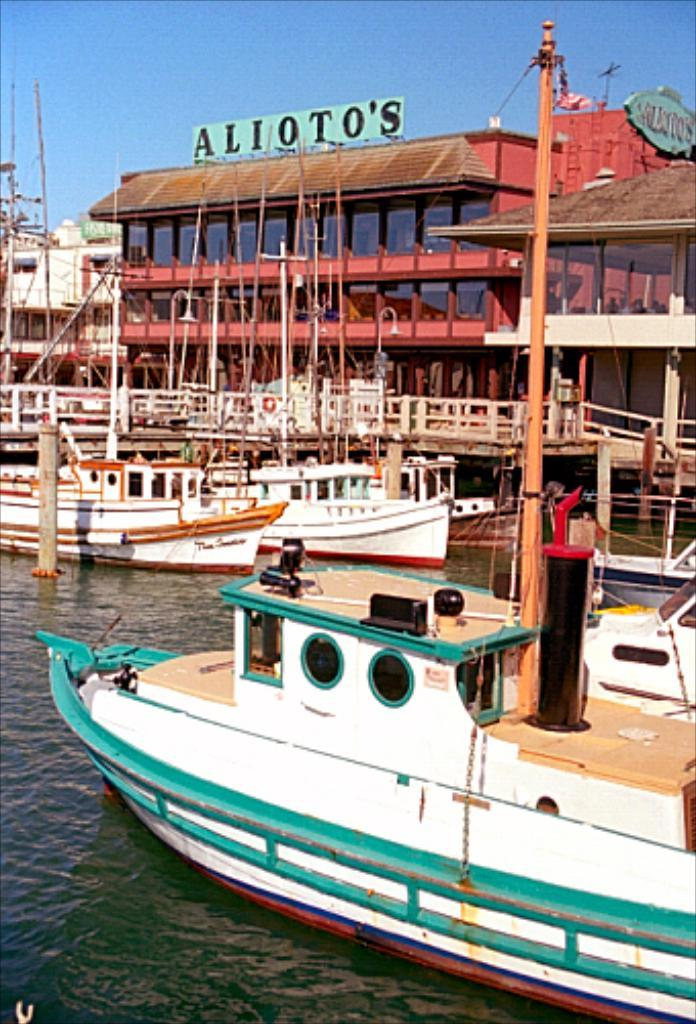What is in the water in the image? There are boats in the water in the image. What can be seen in the background of the image? There are buildings in the background of the image. Can you see a cat playing with a star in the sink in the image? No, there is no cat, star, or sink present in the image. 